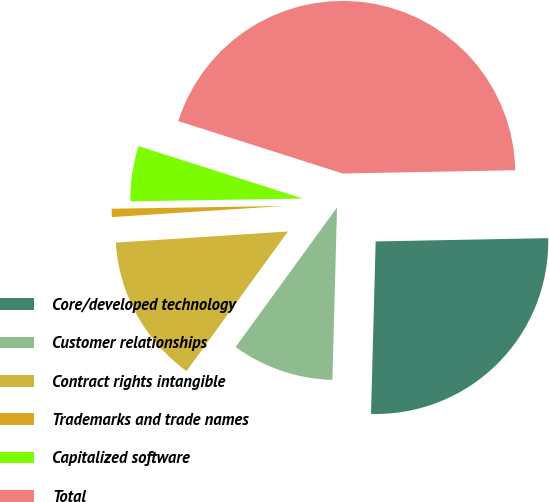Convert chart. <chart><loc_0><loc_0><loc_500><loc_500><pie_chart><fcel>Core/developed technology<fcel>Customer relationships<fcel>Contract rights intangible<fcel>Trademarks and trade names<fcel>Capitalized software<fcel>Total<nl><fcel>25.73%<fcel>9.57%<fcel>13.97%<fcel>0.77%<fcel>5.17%<fcel>44.78%<nl></chart> 